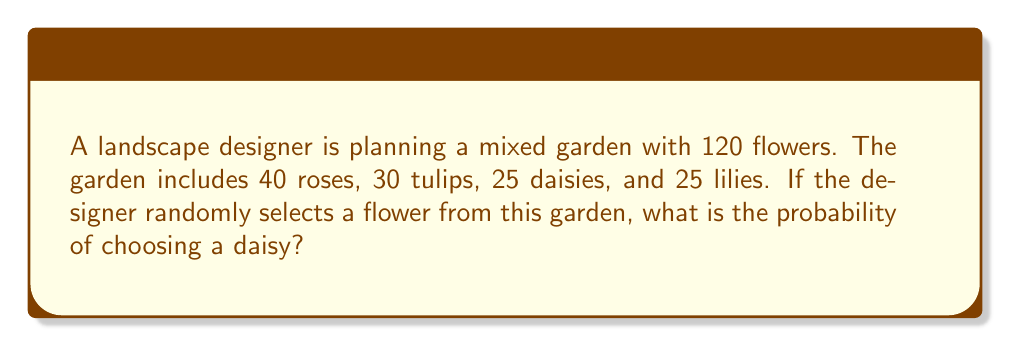Show me your answer to this math problem. Let's approach this step-by-step:

1) First, we need to identify the total number of flowers and the number of daisies:
   - Total flowers: $120$
   - Number of daisies: $25$

2) The probability of an event is calculated by dividing the number of favorable outcomes by the total number of possible outcomes:

   $$P(\text{event}) = \frac{\text{favorable outcomes}}{\text{total outcomes}}$$

3) In this case:
   - Favorable outcomes: selecting a daisy ($25$)
   - Total outcomes: selecting any flower ($120$)

4) Therefore, the probability of selecting a daisy is:

   $$P(\text{daisy}) = \frac{25}{120}$$

5) This fraction can be simplified:
   
   $$\frac{25}{120} = \frac{5}{24}$$

Thus, the probability of the landscape designer randomly selecting a daisy from this mixed garden is $\frac{5}{24}$.
Answer: $\frac{5}{24}$ 